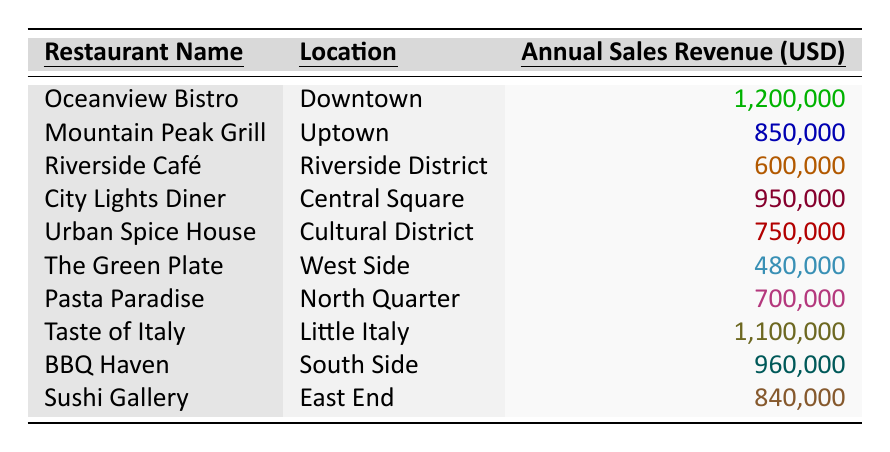What is the highest annual sales revenue among the restaurants? The table shows that "Oceanview Bistro" has the highest revenue listed at 1,200,000 USD.
Answer: 1,200,000 USD What is the annual sales revenue of the "City Lights Diner"? According to the table, "City Lights Diner" has an annual sales revenue of 950,000 USD.
Answer: 950,000 USD Which restaurant located in "Uptown" has an annual sales revenue of 850,000 USD? The restaurant listed in "Uptown" with an annual sales revenue of 850,000 USD is "Mountain Peak Grill."
Answer: Mountain Peak Grill What is the total annual sales revenue of "BBQ Haven" and "Sushi Gallery"? From the table, "BBQ Haven" has a revenue of 960,000 USD and "Sushi Gallery" has 840,000 USD. Adding them together: 960,000 + 840,000 = 1,800,000 USD.
Answer: 1,800,000 USD Which restaurant has the lowest annual sales revenue? The table shows that "The Green Plate" has the lowest revenue at 480,000 USD.
Answer: 480,000 USD What is the average annual sales revenue of all the restaurants listed? To find the average, we first sum the revenues: 1,200,000 + 850,000 + 600,000 + 950,000 + 750,000 + 480,000 + 700,000 + 1,100,000 + 960,000 + 840,000 = 8,630,000 USD. There are 10 restaurants, so the average is 8,630,000 / 10 = 863,000 USD.
Answer: 863,000 USD Is the annual sales revenue of "Taste of Italy" greater than that of "Urban Spice House"? "Taste of Italy" has a revenue of 1,100,000 USD while "Urban Spice House" has 750,000 USD, so yes, it is greater.
Answer: Yes What is the difference in annual sales revenue between "Oceanview Bistro" and "Pasta Paradise"? "Oceanview Bistro" has revenue of 1,200,000 USD and "Pasta Paradise" has 700,000 USD. The difference is 1,200,000 - 700,000 = 500,000 USD.
Answer: 500,000 USD List the locations of restaurants with annual sales revenue above 800,000 USD. The restaurants with revenue above 800,000 USD are "Oceanview Bistro" (Downtown), "Taste of Italy" (Little Italy), "BBQ Haven" (South Side), "City Lights Diner" (Central Square), and "Mountain Peak Grill" (Uptown).
Answer: Downtown, Little Italy, South Side, Central Square, Uptown What percentage of total sales revenue does "Riverside Café" represent? "Riverside Café" has 600,000 USD, and the total sales revenue is 8,630,000 USD. The percentage is (600,000 / 8,630,000) * 100 = approximately 6.95%.
Answer: Approximately 6.95% 